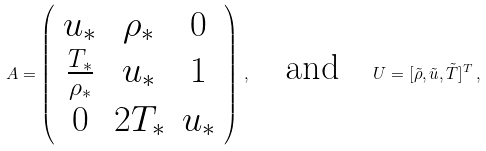<formula> <loc_0><loc_0><loc_500><loc_500>A = \left ( \begin{array} { c c c } u _ { * } & \rho _ { * } & 0 \\ \frac { T _ { * } } { \rho _ { * } } & u _ { * } & 1 \\ 0 & 2 T _ { * } & u _ { * } \\ \end{array} \right ) \, , \quad \text {and} \quad U = [ \tilde { \rho } , \tilde { u } , \tilde { T } ] ^ { T } \, ,</formula> 